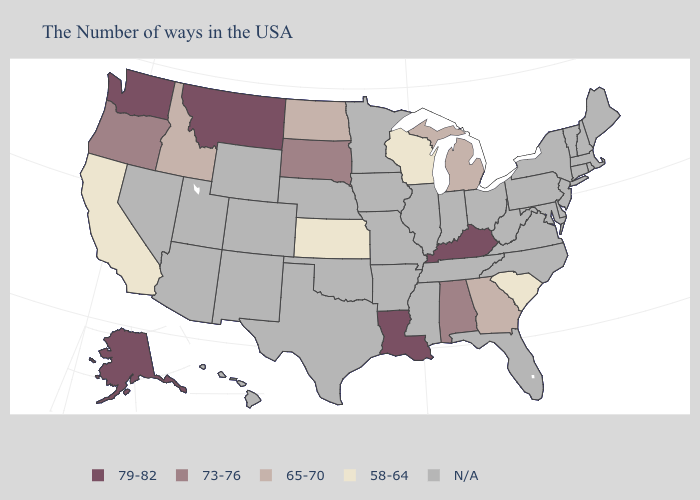Name the states that have a value in the range 65-70?
Answer briefly. Georgia, Michigan, North Dakota, Idaho. Name the states that have a value in the range 65-70?
Answer briefly. Georgia, Michigan, North Dakota, Idaho. Name the states that have a value in the range 73-76?
Concise answer only. Alabama, South Dakota, Oregon. What is the lowest value in states that border Ohio?
Answer briefly. 65-70. Does the map have missing data?
Keep it brief. Yes. Does South Carolina have the highest value in the South?
Write a very short answer. No. Name the states that have a value in the range 65-70?
Short answer required. Georgia, Michigan, North Dakota, Idaho. Does Alaska have the lowest value in the USA?
Answer briefly. No. What is the lowest value in states that border Indiana?
Be succinct. 65-70. What is the value of Nevada?
Write a very short answer. N/A. Name the states that have a value in the range 73-76?
Answer briefly. Alabama, South Dakota, Oregon. What is the value of Mississippi?
Answer briefly. N/A. What is the highest value in the South ?
Answer briefly. 79-82. 